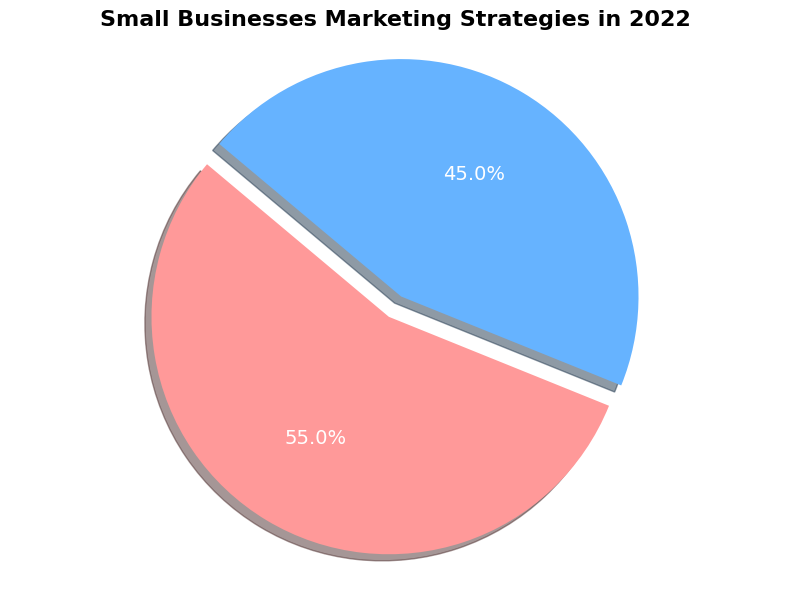what is the percentage of small businesses using traditional marketing strategies in 2022? Look at the portion of the pie chart labeled "Traditional" and identify the percentage value displayed.
Answer: 55% How has the proportion of small businesses utilizing disruptive marketing strategies changed over the past 5 years? The pie chart only shows the data for the latest year, but comparing the latest percentage (45%) with the historical data, we can see an increase from 25% in 2018 to 45% in 2022.
Answer: Increased Which marketing strategy had a larger proportion of small businesses in 2022? Compare the perceivable sizes of the two segments in the pie chart and the actual percentage values. "Traditional" has a larger segment (55% vs. 45%).
Answer: Traditional What is the difference between the proportions of small businesses using traditional and disruptive marketing strategies in 2022? Subtract the percentage of businesses using disruptive strategies (45%) from those using traditional strategies (55%). 55% - 45% = 10%.
Answer: 10% What does the visual indication (color) for traditional marketing strategies look like in the pie chart? Identify the color associated with the "Traditional" portion of the pie chart.
Answer: Red If the percentages of small businesses using disruptive strategies increased linearly over the past 5 years, by what percentage did it increase each year on average? Calculate the overall increase from 2018 to 2022, which is 45% - 25% = 20%, then divide by the number of years (4) to find the average annual increase. 20% ÷ 4 = 5% per year.
Answer: 5% By what percentage did the proportion of small businesses using traditional marketing strategies reduce from 2021 to 2022? Find the difference between the 2021 and 2022 percentages for traditional strategies (60% - 55% = 5%), then calculate this as a percentage of the 2021 value (5% ÷ 60% * 100%).
Answer: 8.33% 